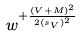<formula> <loc_0><loc_0><loc_500><loc_500>w ^ { + \frac { ( V + M ) ^ { 2 } } { 2 { ( s _ { V } ) } ^ { 2 } } }</formula> 